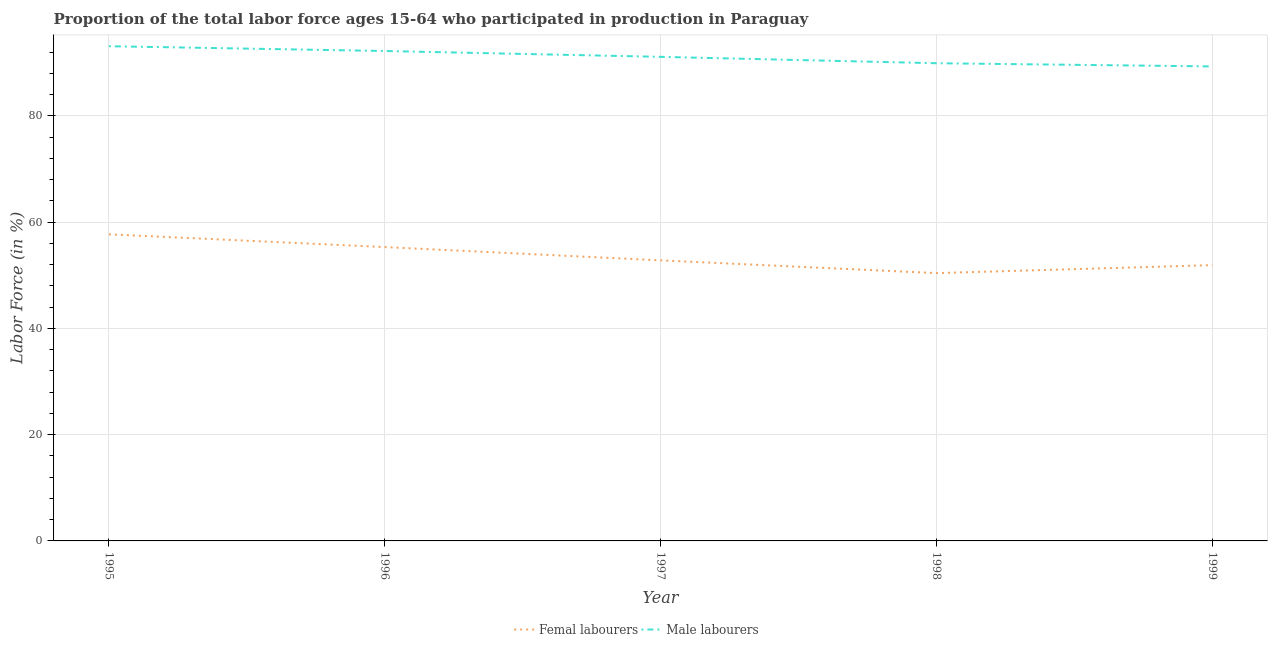Does the line corresponding to percentage of female labor force intersect with the line corresponding to percentage of male labour force?
Provide a short and direct response. No. What is the percentage of male labour force in 1999?
Your response must be concise. 89.3. Across all years, what is the maximum percentage of male labour force?
Offer a terse response. 93.1. Across all years, what is the minimum percentage of female labor force?
Provide a succinct answer. 50.4. In which year was the percentage of female labor force maximum?
Provide a short and direct response. 1995. What is the total percentage of male labour force in the graph?
Offer a very short reply. 455.6. What is the difference between the percentage of male labour force in 1999 and the percentage of female labor force in 1997?
Keep it short and to the point. 36.5. What is the average percentage of female labor force per year?
Offer a very short reply. 53.62. In the year 1998, what is the difference between the percentage of female labor force and percentage of male labour force?
Keep it short and to the point. -39.5. In how many years, is the percentage of female labor force greater than 80 %?
Your answer should be compact. 0. What is the ratio of the percentage of female labor force in 1996 to that in 1999?
Your answer should be very brief. 1.07. Is the difference between the percentage of female labor force in 1995 and 1996 greater than the difference between the percentage of male labour force in 1995 and 1996?
Provide a succinct answer. Yes. What is the difference between the highest and the second highest percentage of female labor force?
Your response must be concise. 2.4. What is the difference between the highest and the lowest percentage of female labor force?
Provide a short and direct response. 7.3. In how many years, is the percentage of female labor force greater than the average percentage of female labor force taken over all years?
Your response must be concise. 2. Is the sum of the percentage of male labour force in 1995 and 1998 greater than the maximum percentage of female labor force across all years?
Provide a succinct answer. Yes. Does the percentage of female labor force monotonically increase over the years?
Offer a very short reply. No. Is the percentage of male labour force strictly greater than the percentage of female labor force over the years?
Make the answer very short. Yes. Is the percentage of female labor force strictly less than the percentage of male labour force over the years?
Offer a very short reply. Yes. How many lines are there?
Offer a terse response. 2. How many years are there in the graph?
Provide a succinct answer. 5. Does the graph contain any zero values?
Your answer should be compact. No. How are the legend labels stacked?
Ensure brevity in your answer.  Horizontal. What is the title of the graph?
Keep it short and to the point. Proportion of the total labor force ages 15-64 who participated in production in Paraguay. What is the label or title of the X-axis?
Your answer should be very brief. Year. What is the label or title of the Y-axis?
Make the answer very short. Labor Force (in %). What is the Labor Force (in %) of Femal labourers in 1995?
Give a very brief answer. 57.7. What is the Labor Force (in %) in Male labourers in 1995?
Make the answer very short. 93.1. What is the Labor Force (in %) of Femal labourers in 1996?
Give a very brief answer. 55.3. What is the Labor Force (in %) of Male labourers in 1996?
Provide a succinct answer. 92.2. What is the Labor Force (in %) in Femal labourers in 1997?
Your response must be concise. 52.8. What is the Labor Force (in %) of Male labourers in 1997?
Make the answer very short. 91.1. What is the Labor Force (in %) of Femal labourers in 1998?
Your answer should be compact. 50.4. What is the Labor Force (in %) of Male labourers in 1998?
Give a very brief answer. 89.9. What is the Labor Force (in %) in Femal labourers in 1999?
Offer a very short reply. 51.9. What is the Labor Force (in %) in Male labourers in 1999?
Offer a terse response. 89.3. Across all years, what is the maximum Labor Force (in %) in Femal labourers?
Ensure brevity in your answer.  57.7. Across all years, what is the maximum Labor Force (in %) of Male labourers?
Offer a very short reply. 93.1. Across all years, what is the minimum Labor Force (in %) in Femal labourers?
Offer a very short reply. 50.4. Across all years, what is the minimum Labor Force (in %) in Male labourers?
Keep it short and to the point. 89.3. What is the total Labor Force (in %) in Femal labourers in the graph?
Give a very brief answer. 268.1. What is the total Labor Force (in %) of Male labourers in the graph?
Your answer should be compact. 455.6. What is the difference between the Labor Force (in %) in Femal labourers in 1995 and that in 1998?
Keep it short and to the point. 7.3. What is the difference between the Labor Force (in %) of Male labourers in 1995 and that in 1998?
Make the answer very short. 3.2. What is the difference between the Labor Force (in %) in Femal labourers in 1995 and that in 1999?
Provide a succinct answer. 5.8. What is the difference between the Labor Force (in %) in Femal labourers in 1996 and that in 1997?
Provide a short and direct response. 2.5. What is the difference between the Labor Force (in %) of Male labourers in 1996 and that in 1997?
Your answer should be very brief. 1.1. What is the difference between the Labor Force (in %) of Femal labourers in 1996 and that in 1998?
Offer a terse response. 4.9. What is the difference between the Labor Force (in %) of Femal labourers in 1997 and that in 1998?
Give a very brief answer. 2.4. What is the difference between the Labor Force (in %) in Male labourers in 1997 and that in 1999?
Your response must be concise. 1.8. What is the difference between the Labor Force (in %) in Femal labourers in 1998 and that in 1999?
Your response must be concise. -1.5. What is the difference between the Labor Force (in %) of Male labourers in 1998 and that in 1999?
Your answer should be compact. 0.6. What is the difference between the Labor Force (in %) of Femal labourers in 1995 and the Labor Force (in %) of Male labourers in 1996?
Provide a succinct answer. -34.5. What is the difference between the Labor Force (in %) of Femal labourers in 1995 and the Labor Force (in %) of Male labourers in 1997?
Give a very brief answer. -33.4. What is the difference between the Labor Force (in %) in Femal labourers in 1995 and the Labor Force (in %) in Male labourers in 1998?
Provide a succinct answer. -32.2. What is the difference between the Labor Force (in %) of Femal labourers in 1995 and the Labor Force (in %) of Male labourers in 1999?
Give a very brief answer. -31.6. What is the difference between the Labor Force (in %) in Femal labourers in 1996 and the Labor Force (in %) in Male labourers in 1997?
Ensure brevity in your answer.  -35.8. What is the difference between the Labor Force (in %) of Femal labourers in 1996 and the Labor Force (in %) of Male labourers in 1998?
Keep it short and to the point. -34.6. What is the difference between the Labor Force (in %) of Femal labourers in 1996 and the Labor Force (in %) of Male labourers in 1999?
Provide a succinct answer. -34. What is the difference between the Labor Force (in %) in Femal labourers in 1997 and the Labor Force (in %) in Male labourers in 1998?
Offer a terse response. -37.1. What is the difference between the Labor Force (in %) of Femal labourers in 1997 and the Labor Force (in %) of Male labourers in 1999?
Keep it short and to the point. -36.5. What is the difference between the Labor Force (in %) in Femal labourers in 1998 and the Labor Force (in %) in Male labourers in 1999?
Your answer should be compact. -38.9. What is the average Labor Force (in %) of Femal labourers per year?
Your answer should be compact. 53.62. What is the average Labor Force (in %) of Male labourers per year?
Give a very brief answer. 91.12. In the year 1995, what is the difference between the Labor Force (in %) of Femal labourers and Labor Force (in %) of Male labourers?
Offer a terse response. -35.4. In the year 1996, what is the difference between the Labor Force (in %) in Femal labourers and Labor Force (in %) in Male labourers?
Your answer should be very brief. -36.9. In the year 1997, what is the difference between the Labor Force (in %) of Femal labourers and Labor Force (in %) of Male labourers?
Offer a very short reply. -38.3. In the year 1998, what is the difference between the Labor Force (in %) of Femal labourers and Labor Force (in %) of Male labourers?
Offer a terse response. -39.5. In the year 1999, what is the difference between the Labor Force (in %) of Femal labourers and Labor Force (in %) of Male labourers?
Ensure brevity in your answer.  -37.4. What is the ratio of the Labor Force (in %) in Femal labourers in 1995 to that in 1996?
Ensure brevity in your answer.  1.04. What is the ratio of the Labor Force (in %) of Male labourers in 1995 to that in 1996?
Give a very brief answer. 1.01. What is the ratio of the Labor Force (in %) of Femal labourers in 1995 to that in 1997?
Your answer should be compact. 1.09. What is the ratio of the Labor Force (in %) in Male labourers in 1995 to that in 1997?
Your answer should be very brief. 1.02. What is the ratio of the Labor Force (in %) of Femal labourers in 1995 to that in 1998?
Your response must be concise. 1.14. What is the ratio of the Labor Force (in %) in Male labourers in 1995 to that in 1998?
Ensure brevity in your answer.  1.04. What is the ratio of the Labor Force (in %) of Femal labourers in 1995 to that in 1999?
Provide a short and direct response. 1.11. What is the ratio of the Labor Force (in %) of Male labourers in 1995 to that in 1999?
Make the answer very short. 1.04. What is the ratio of the Labor Force (in %) in Femal labourers in 1996 to that in 1997?
Offer a very short reply. 1.05. What is the ratio of the Labor Force (in %) in Male labourers in 1996 to that in 1997?
Your answer should be compact. 1.01. What is the ratio of the Labor Force (in %) in Femal labourers in 1996 to that in 1998?
Your answer should be very brief. 1.1. What is the ratio of the Labor Force (in %) in Male labourers in 1996 to that in 1998?
Make the answer very short. 1.03. What is the ratio of the Labor Force (in %) in Femal labourers in 1996 to that in 1999?
Offer a very short reply. 1.07. What is the ratio of the Labor Force (in %) of Male labourers in 1996 to that in 1999?
Your answer should be compact. 1.03. What is the ratio of the Labor Force (in %) of Femal labourers in 1997 to that in 1998?
Ensure brevity in your answer.  1.05. What is the ratio of the Labor Force (in %) of Male labourers in 1997 to that in 1998?
Keep it short and to the point. 1.01. What is the ratio of the Labor Force (in %) in Femal labourers in 1997 to that in 1999?
Provide a succinct answer. 1.02. What is the ratio of the Labor Force (in %) of Male labourers in 1997 to that in 1999?
Give a very brief answer. 1.02. What is the ratio of the Labor Force (in %) in Femal labourers in 1998 to that in 1999?
Your answer should be compact. 0.97. What is the difference between the highest and the second highest Labor Force (in %) of Femal labourers?
Give a very brief answer. 2.4. What is the difference between the highest and the second highest Labor Force (in %) in Male labourers?
Provide a short and direct response. 0.9. What is the difference between the highest and the lowest Labor Force (in %) of Male labourers?
Provide a short and direct response. 3.8. 